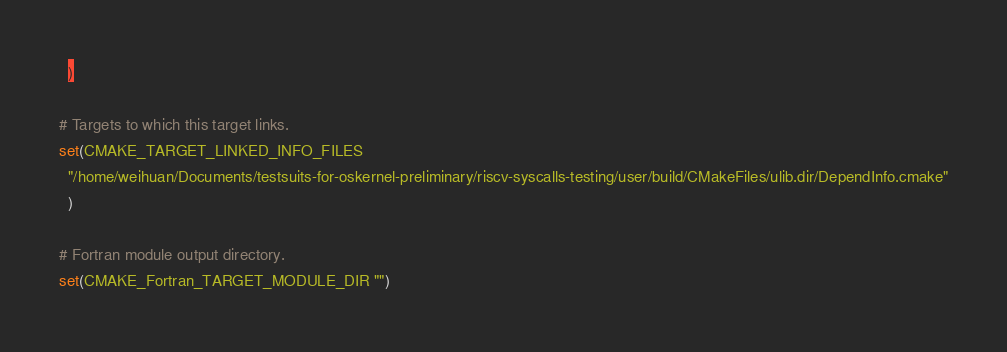<code> <loc_0><loc_0><loc_500><loc_500><_CMake_>  )

# Targets to which this target links.
set(CMAKE_TARGET_LINKED_INFO_FILES
  "/home/weihuan/Documents/testsuits-for-oskernel-preliminary/riscv-syscalls-testing/user/build/CMakeFiles/ulib.dir/DependInfo.cmake"
  )

# Fortran module output directory.
set(CMAKE_Fortran_TARGET_MODULE_DIR "")
</code> 